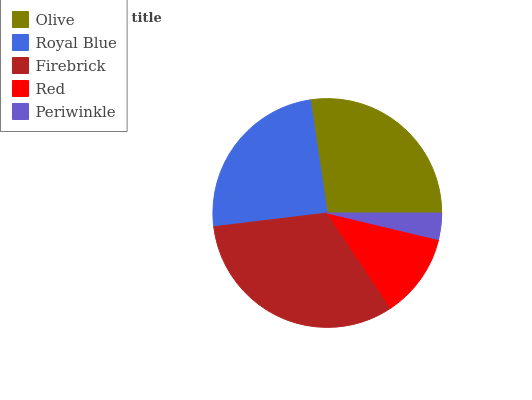Is Periwinkle the minimum?
Answer yes or no. Yes. Is Firebrick the maximum?
Answer yes or no. Yes. Is Royal Blue the minimum?
Answer yes or no. No. Is Royal Blue the maximum?
Answer yes or no. No. Is Olive greater than Royal Blue?
Answer yes or no. Yes. Is Royal Blue less than Olive?
Answer yes or no. Yes. Is Royal Blue greater than Olive?
Answer yes or no. No. Is Olive less than Royal Blue?
Answer yes or no. No. Is Royal Blue the high median?
Answer yes or no. Yes. Is Royal Blue the low median?
Answer yes or no. Yes. Is Red the high median?
Answer yes or no. No. Is Red the low median?
Answer yes or no. No. 